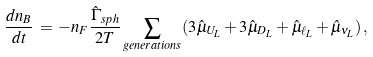Convert formula to latex. <formula><loc_0><loc_0><loc_500><loc_500>\frac { d n _ { B } } { d t } \, = \, - n _ { F } \frac { \hat { \Gamma } _ { s p h } } { 2 T } \sum _ { g e n e r a t i o n s } ( 3 \hat { \mu } _ { U _ { L } } + 3 \hat { \mu } _ { D _ { L } } + \hat { \mu } _ { \ell _ { L } } + \hat { \mu } _ { \nu _ { L } } ) \, ,</formula> 